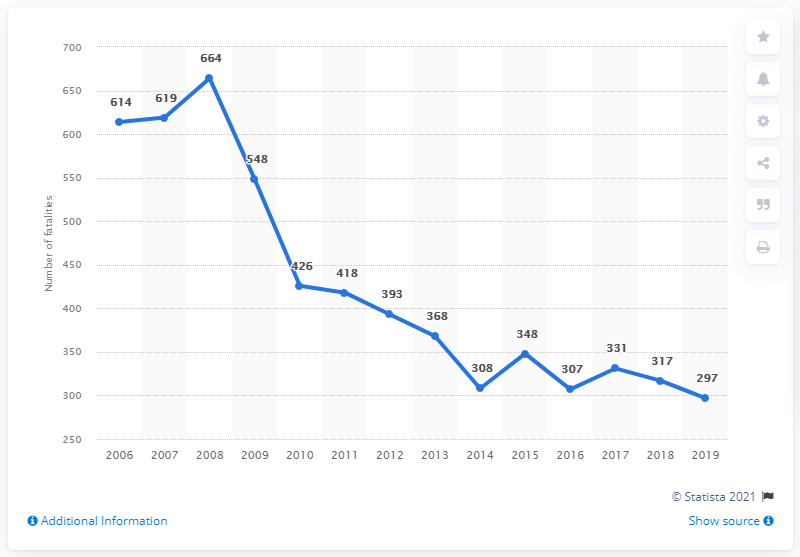Mention a couple of crucial points in this snapshot. In 2016, the number of road traffic fatalities was at its lowest point. The sum of fatalities in 2018 and 2019 is 614. In 2008, the highest number of road traffic fatalities was recorded. In 2019, Croatia reported 297 road traffic fatalities. 